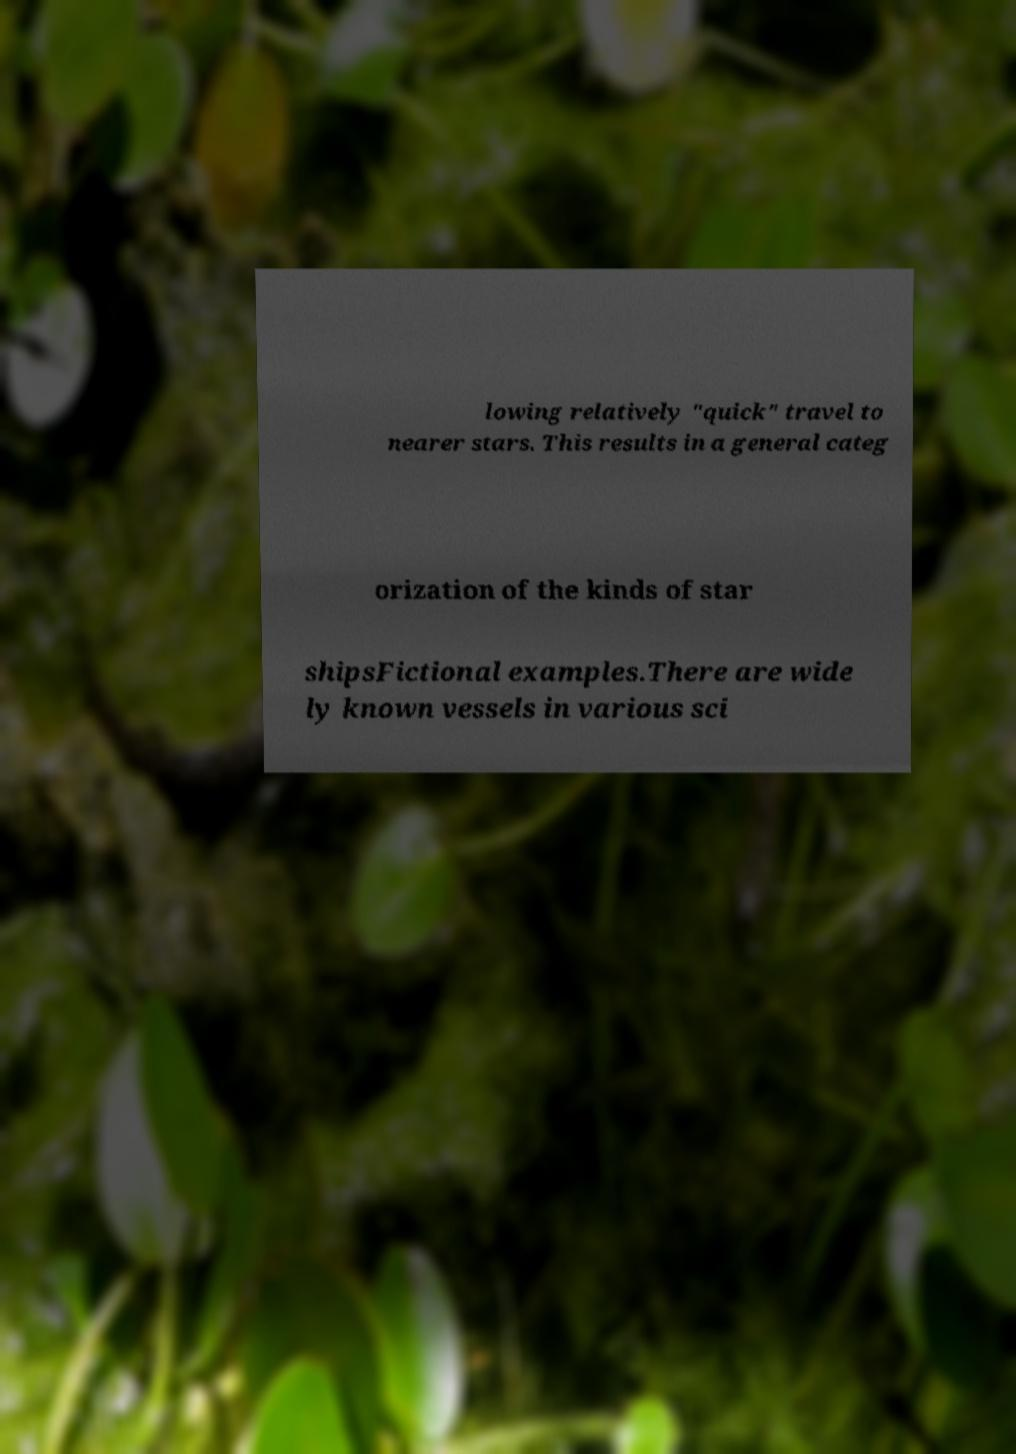Please read and relay the text visible in this image. What does it say? lowing relatively "quick" travel to nearer stars. This results in a general categ orization of the kinds of star shipsFictional examples.There are wide ly known vessels in various sci 